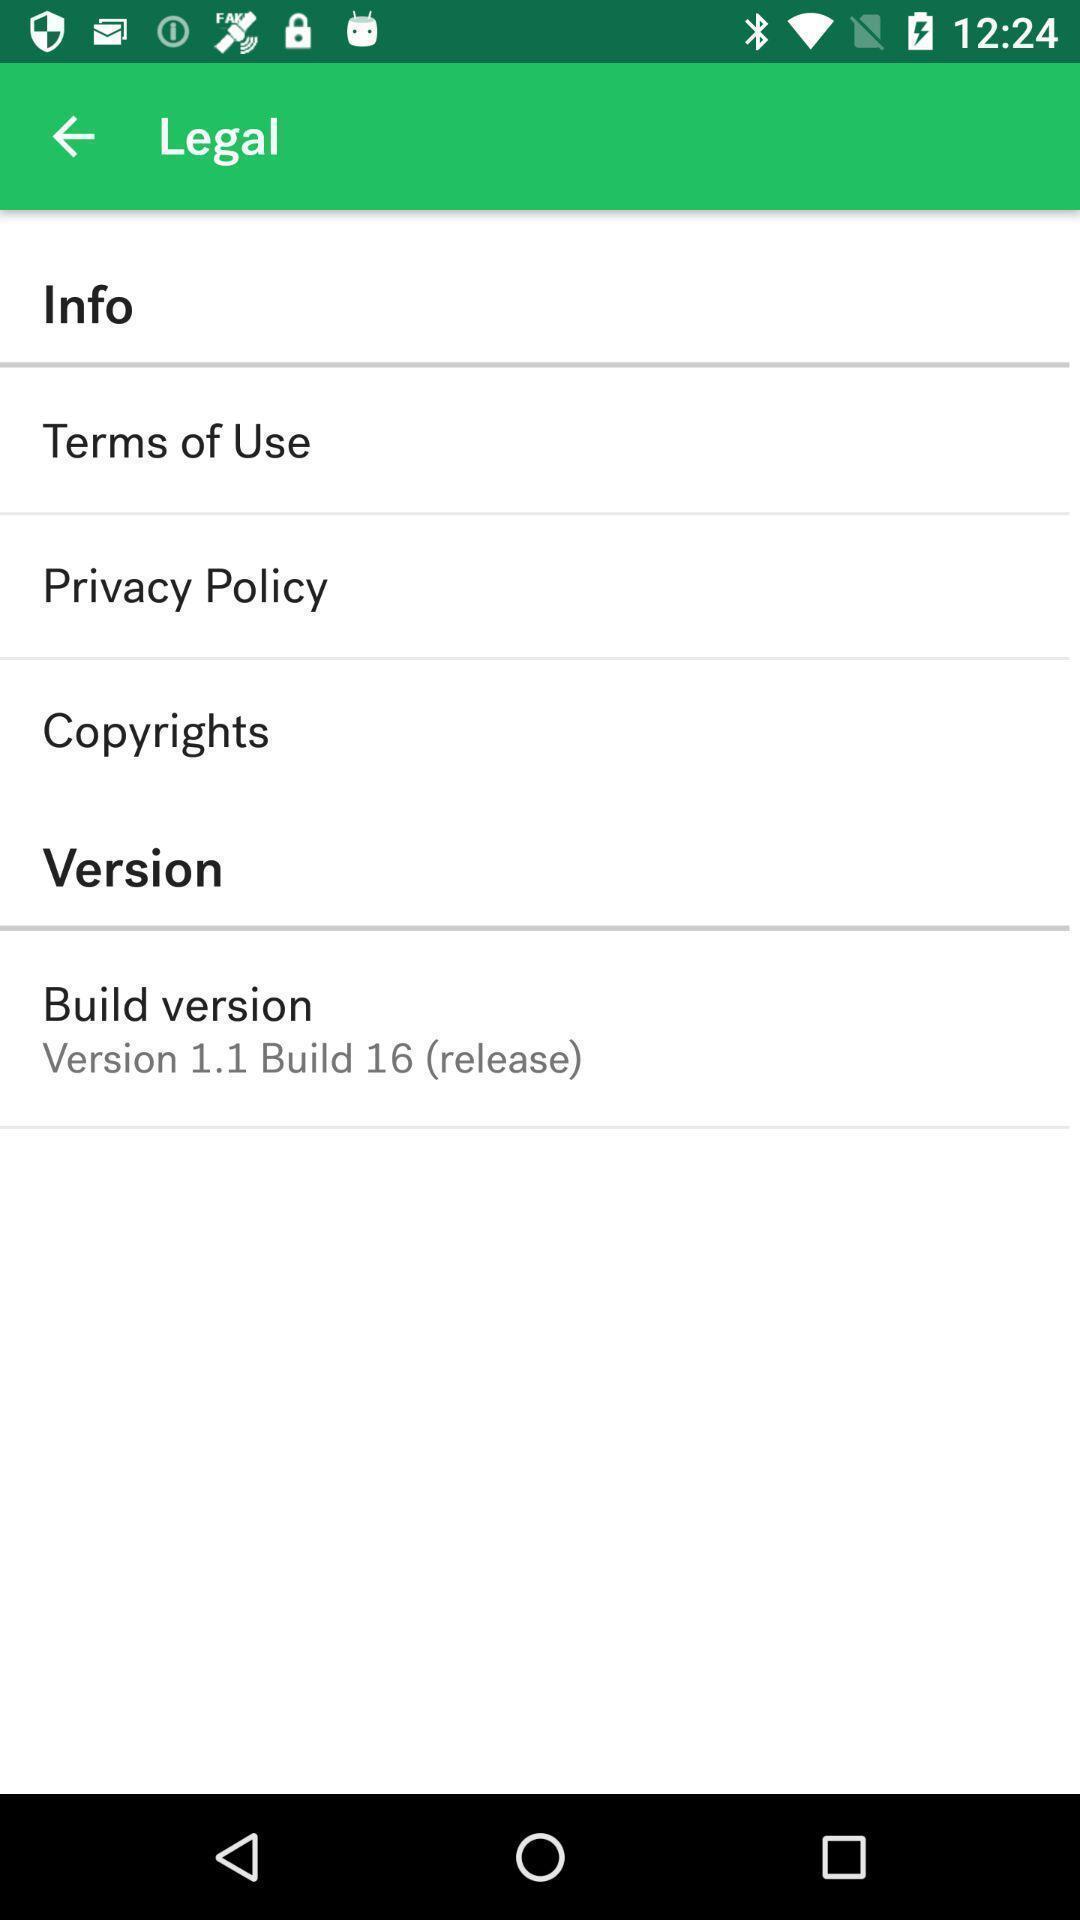What can you discern from this picture? Page displaying the app information. 